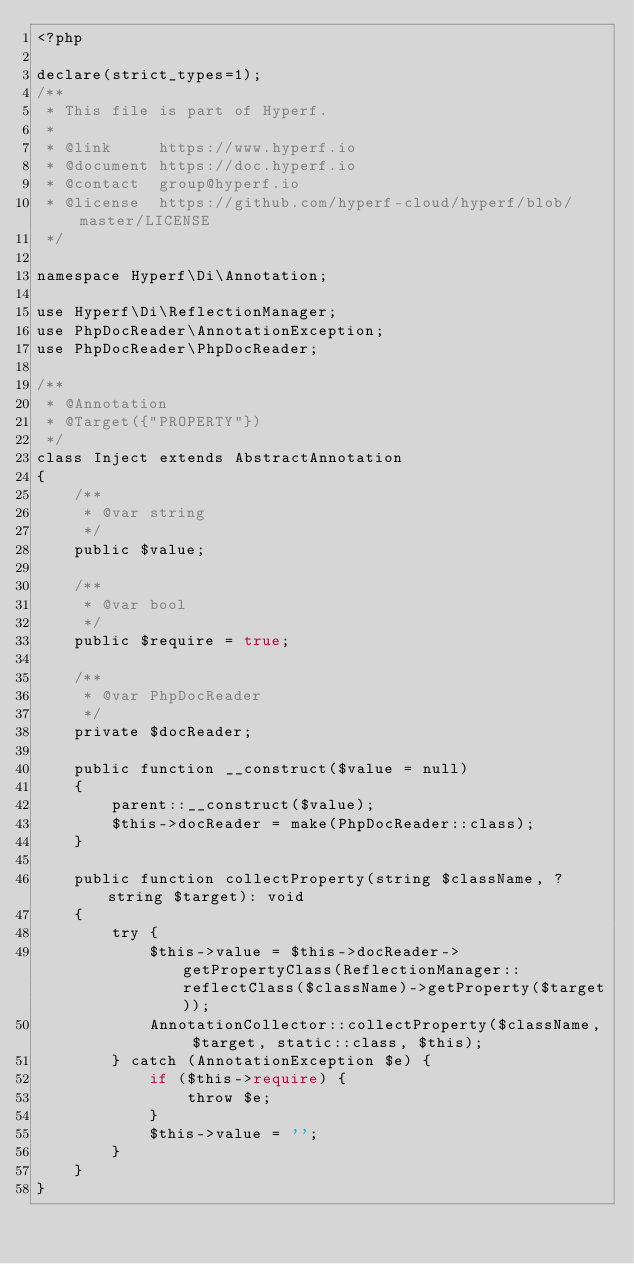Convert code to text. <code><loc_0><loc_0><loc_500><loc_500><_PHP_><?php

declare(strict_types=1);
/**
 * This file is part of Hyperf.
 *
 * @link     https://www.hyperf.io
 * @document https://doc.hyperf.io
 * @contact  group@hyperf.io
 * @license  https://github.com/hyperf-cloud/hyperf/blob/master/LICENSE
 */

namespace Hyperf\Di\Annotation;

use Hyperf\Di\ReflectionManager;
use PhpDocReader\AnnotationException;
use PhpDocReader\PhpDocReader;

/**
 * @Annotation
 * @Target({"PROPERTY"})
 */
class Inject extends AbstractAnnotation
{
    /**
     * @var string
     */
    public $value;

    /**
     * @var bool
     */
    public $require = true;

    /**
     * @var PhpDocReader
     */
    private $docReader;

    public function __construct($value = null)
    {
        parent::__construct($value);
        $this->docReader = make(PhpDocReader::class);
    }

    public function collectProperty(string $className, ?string $target): void
    {
        try {
            $this->value = $this->docReader->getPropertyClass(ReflectionManager::reflectClass($className)->getProperty($target));
            AnnotationCollector::collectProperty($className, $target, static::class, $this);
        } catch (AnnotationException $e) {
            if ($this->require) {
                throw $e;
            }
            $this->value = '';
        }
    }
}
</code> 